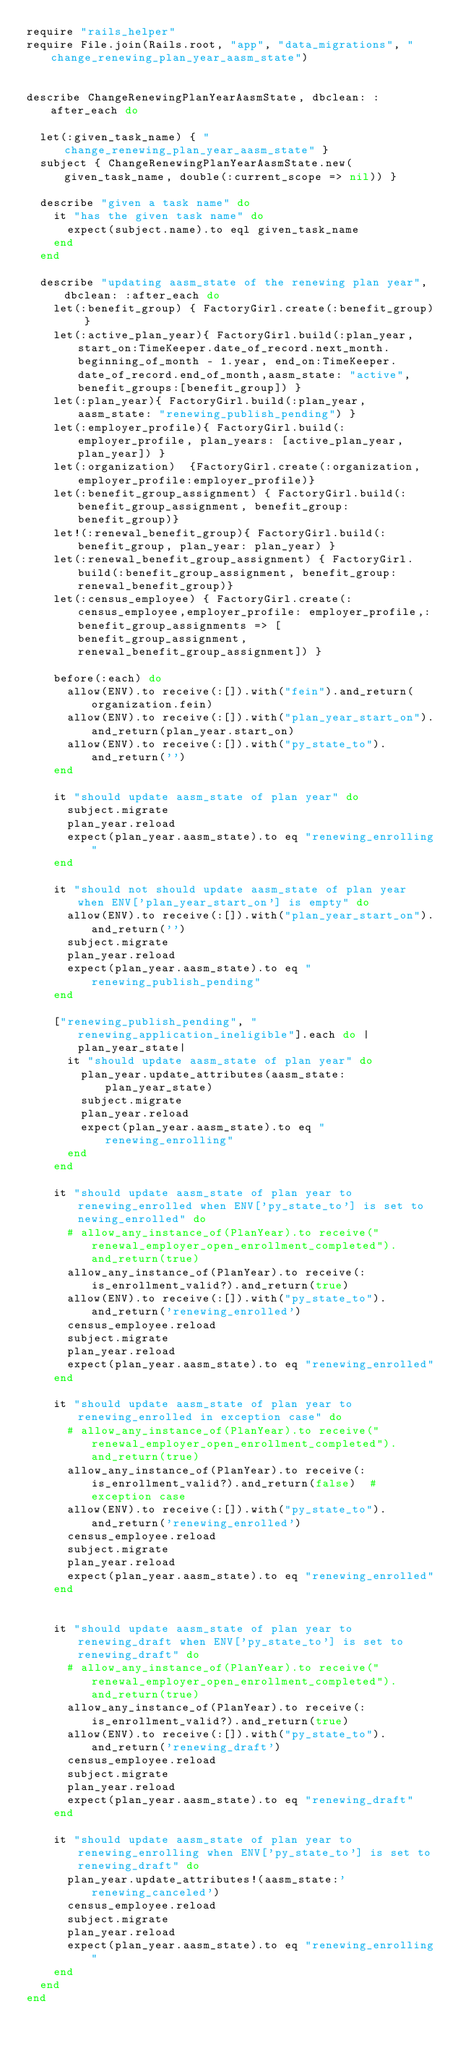<code> <loc_0><loc_0><loc_500><loc_500><_Ruby_>require "rails_helper"
require File.join(Rails.root, "app", "data_migrations", "change_renewing_plan_year_aasm_state")


describe ChangeRenewingPlanYearAasmState, dbclean: :after_each do

  let(:given_task_name) { "change_renewing_plan_year_aasm_state" }
  subject { ChangeRenewingPlanYearAasmState.new(given_task_name, double(:current_scope => nil)) }

  describe "given a task name" do
    it "has the given task name" do
      expect(subject.name).to eql given_task_name
    end
  end

  describe "updating aasm_state of the renewing plan year", dbclean: :after_each do
    let(:benefit_group) { FactoryGirl.create(:benefit_group) }
    let(:active_plan_year){ FactoryGirl.build(:plan_year,start_on:TimeKeeper.date_of_record.next_month.beginning_of_month - 1.year, end_on:TimeKeeper.date_of_record.end_of_month,aasm_state: "active",benefit_groups:[benefit_group]) }
    let(:plan_year){ FactoryGirl.build(:plan_year, aasm_state: "renewing_publish_pending") }
    let(:employer_profile){ FactoryGirl.build(:employer_profile, plan_years: [active_plan_year,plan_year]) }
    let(:organization)  {FactoryGirl.create(:organization,employer_profile:employer_profile)}
    let(:benefit_group_assignment) { FactoryGirl.build(:benefit_group_assignment, benefit_group: benefit_group)}
    let!(:renewal_benefit_group){ FactoryGirl.build(:benefit_group, plan_year: plan_year) }
    let(:renewal_benefit_group_assignment) { FactoryGirl.build(:benefit_group_assignment, benefit_group: renewal_benefit_group)}
    let(:census_employee) { FactoryGirl.create(:census_employee,employer_profile: employer_profile,:benefit_group_assignments => [benefit_group_assignment,renewal_benefit_group_assignment]) }

    before(:each) do
      allow(ENV).to receive(:[]).with("fein").and_return(organization.fein)
      allow(ENV).to receive(:[]).with("plan_year_start_on").and_return(plan_year.start_on)
      allow(ENV).to receive(:[]).with("py_state_to").and_return('')
    end

    it "should update aasm_state of plan year" do
      subject.migrate
      plan_year.reload
      expect(plan_year.aasm_state).to eq "renewing_enrolling"
    end

    it "should not should update aasm_state of plan year when ENV['plan_year_start_on'] is empty" do
      allow(ENV).to receive(:[]).with("plan_year_start_on").and_return('')
      subject.migrate
      plan_year.reload
      expect(plan_year.aasm_state).to eq "renewing_publish_pending"
    end

    ["renewing_publish_pending", "renewing_application_ineligible"].each do |plan_year_state|
      it "should update aasm_state of plan year" do
        plan_year.update_attributes(aasm_state: plan_year_state)
        subject.migrate
        plan_year.reload
        expect(plan_year.aasm_state).to eq "renewing_enrolling"
      end
    end

    it "should update aasm_state of plan year to renewing_enrolled when ENV['py_state_to'] is set to newing_enrolled" do
      # allow_any_instance_of(PlanYear).to receive("renewal_employer_open_enrollment_completed").and_return(true)
      allow_any_instance_of(PlanYear).to receive(:is_enrollment_valid?).and_return(true)
      allow(ENV).to receive(:[]).with("py_state_to").and_return('renewing_enrolled')
      census_employee.reload
      subject.migrate
      plan_year.reload
      expect(plan_year.aasm_state).to eq "renewing_enrolled"
    end

    it "should update aasm_state of plan year to renewing_enrolled in exception case" do
      # allow_any_instance_of(PlanYear).to receive("renewal_employer_open_enrollment_completed").and_return(true)
      allow_any_instance_of(PlanYear).to receive(:is_enrollment_valid?).and_return(false)  # exception case
      allow(ENV).to receive(:[]).with("py_state_to").and_return('renewing_enrolled')
      census_employee.reload
      subject.migrate
      plan_year.reload
      expect(plan_year.aasm_state).to eq "renewing_enrolled"
    end


    it "should update aasm_state of plan year to renewing_draft when ENV['py_state_to'] is set to renewing_draft" do
      # allow_any_instance_of(PlanYear).to receive("renewal_employer_open_enrollment_completed").and_return(true)
      allow_any_instance_of(PlanYear).to receive(:is_enrollment_valid?).and_return(true)
      allow(ENV).to receive(:[]).with("py_state_to").and_return('renewing_draft')
      census_employee.reload
      subject.migrate
      plan_year.reload
      expect(plan_year.aasm_state).to eq "renewing_draft"
    end

    it "should update aasm_state of plan year to renewing_enrolling when ENV['py_state_to'] is set to renewing_draft" do
      plan_year.update_attributes!(aasm_state:'renewing_canceled')
      census_employee.reload
      subject.migrate
      plan_year.reload
      expect(plan_year.aasm_state).to eq "renewing_enrolling"
    end
  end
end
</code> 